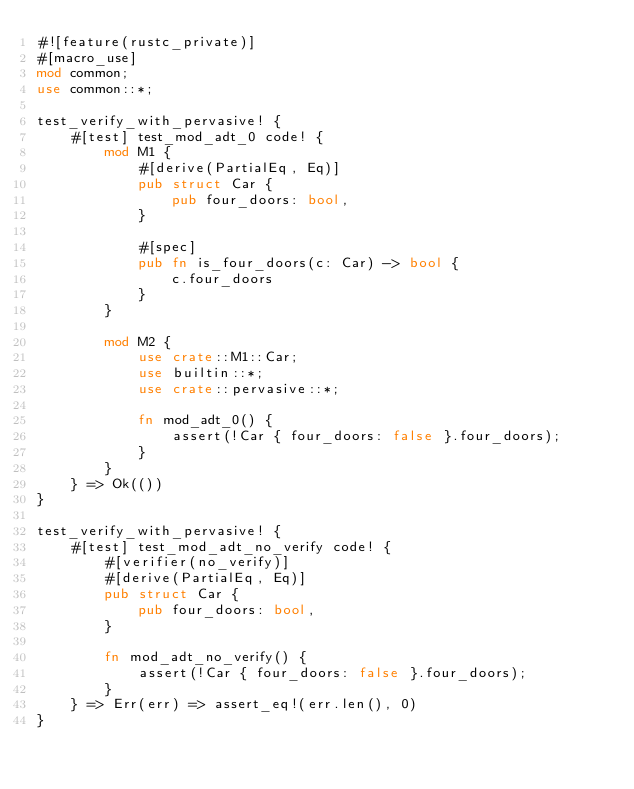<code> <loc_0><loc_0><loc_500><loc_500><_Rust_>#![feature(rustc_private)]
#[macro_use]
mod common;
use common::*;

test_verify_with_pervasive! {
    #[test] test_mod_adt_0 code! {
        mod M1 {
            #[derive(PartialEq, Eq)]
            pub struct Car {
                pub four_doors: bool,
            }

            #[spec]
            pub fn is_four_doors(c: Car) -> bool {
                c.four_doors
            }
        }

        mod M2 {
            use crate::M1::Car;
            use builtin::*;
            use crate::pervasive::*;

            fn mod_adt_0() {
                assert(!Car { four_doors: false }.four_doors);
            }
        }
    } => Ok(())
}

test_verify_with_pervasive! {
    #[test] test_mod_adt_no_verify code! {
        #[verifier(no_verify)]
        #[derive(PartialEq, Eq)]
        pub struct Car {
            pub four_doors: bool,
        }

        fn mod_adt_no_verify() {
            assert(!Car { four_doors: false }.four_doors);
        }
    } => Err(err) => assert_eq!(err.len(), 0)
}
</code> 